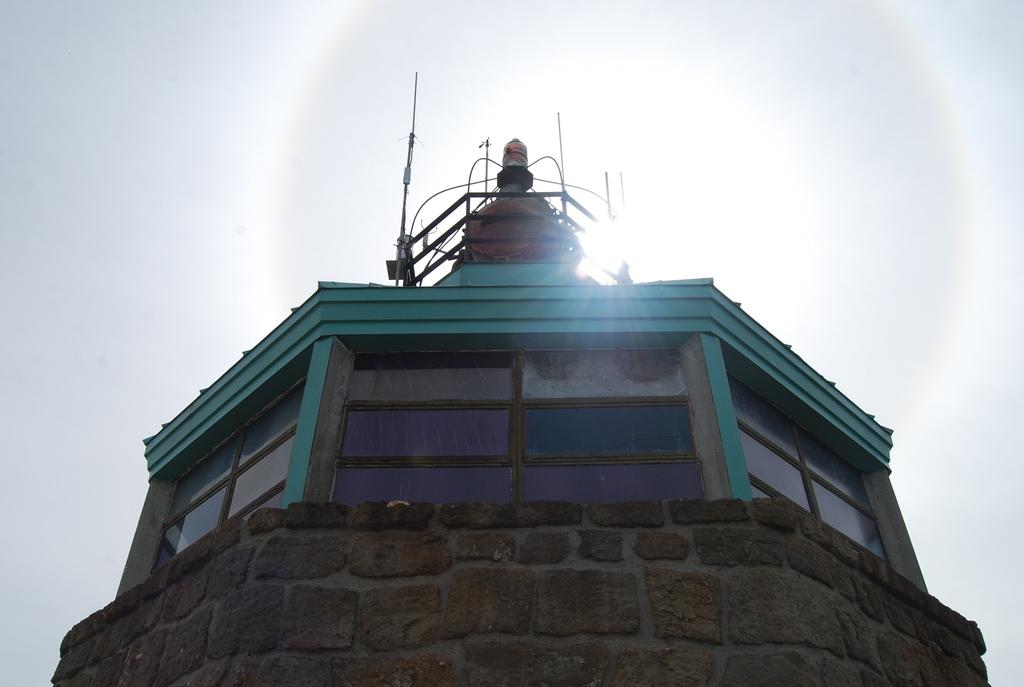What type of structure is in the image? There is a building in the image. What feature can be observed on the building? The building has glass windows. What can be seen in the background of the image? The sky is visible in the background of the image. What type of leather material is used to frame the flower in the image? There is no flower or leather material present in the image. 